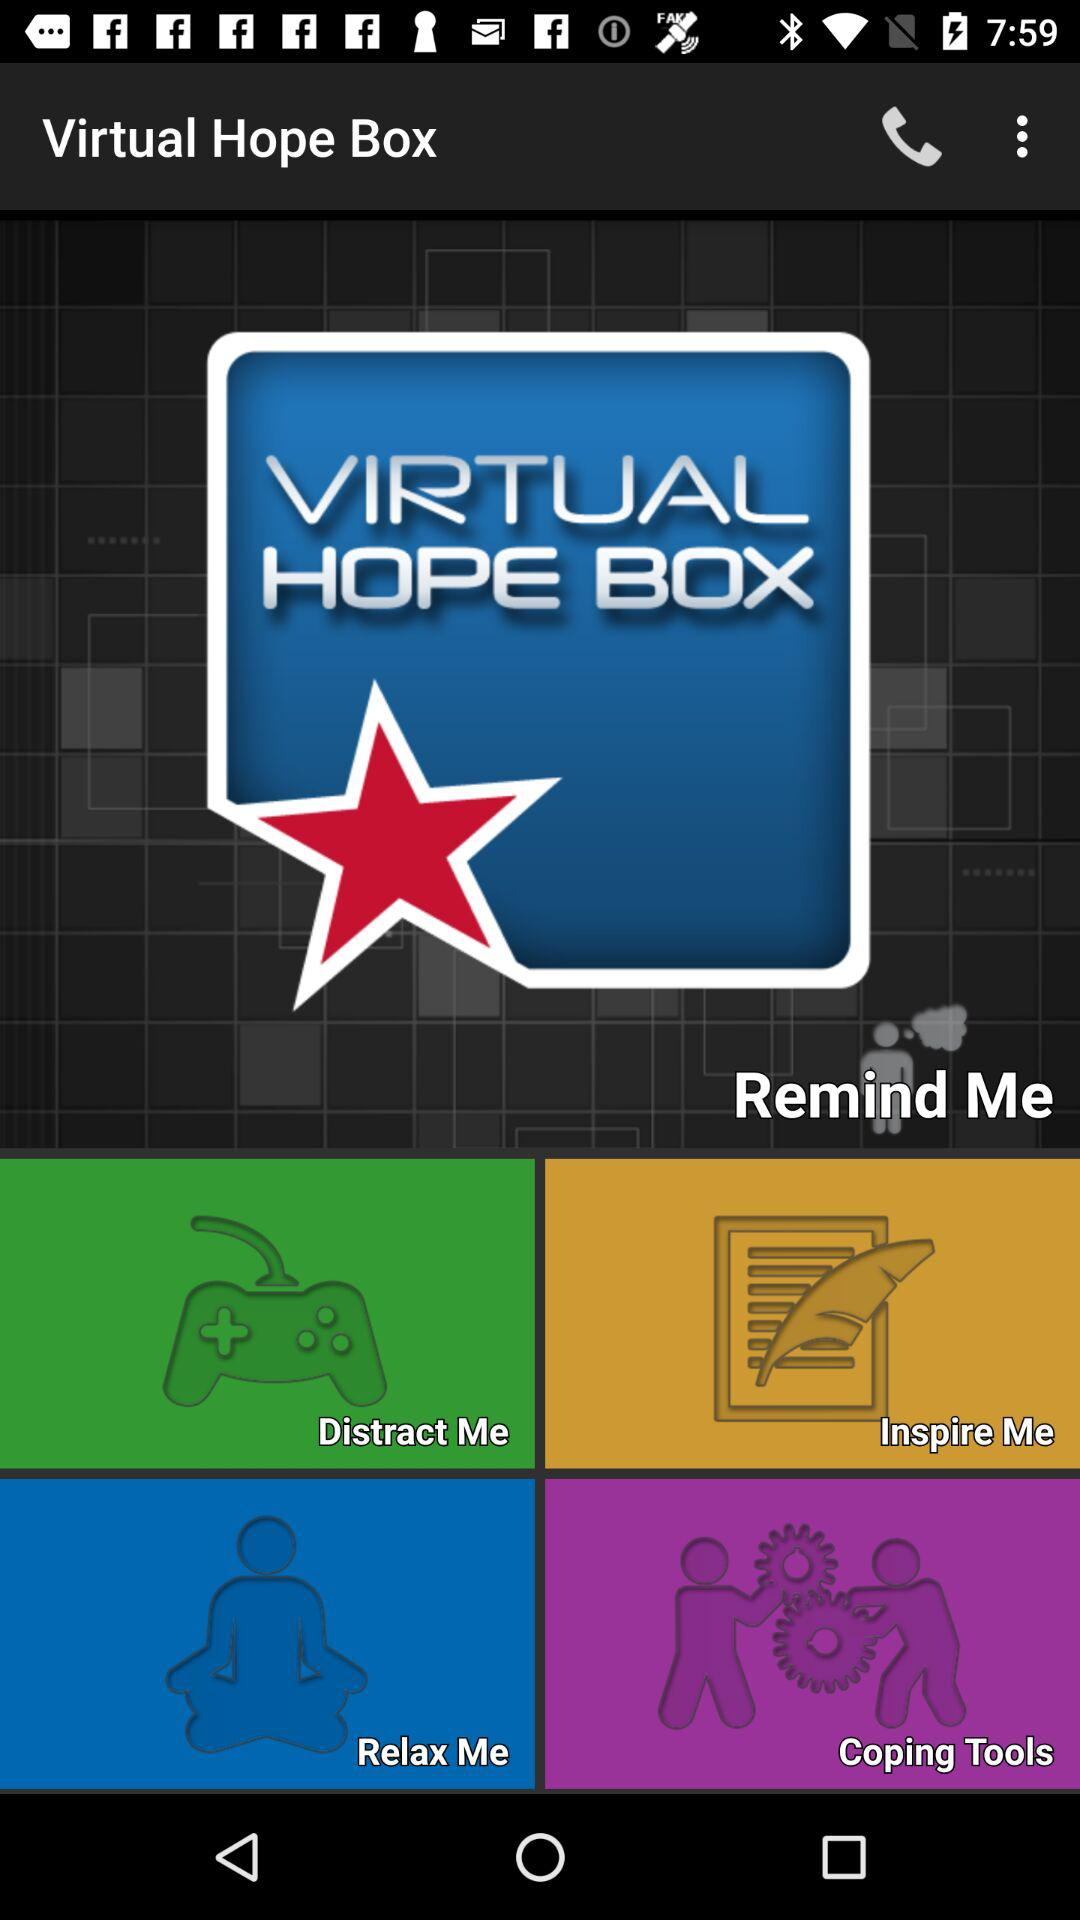What is the name of the application? The name of the application is "Virtual Hope Box". 